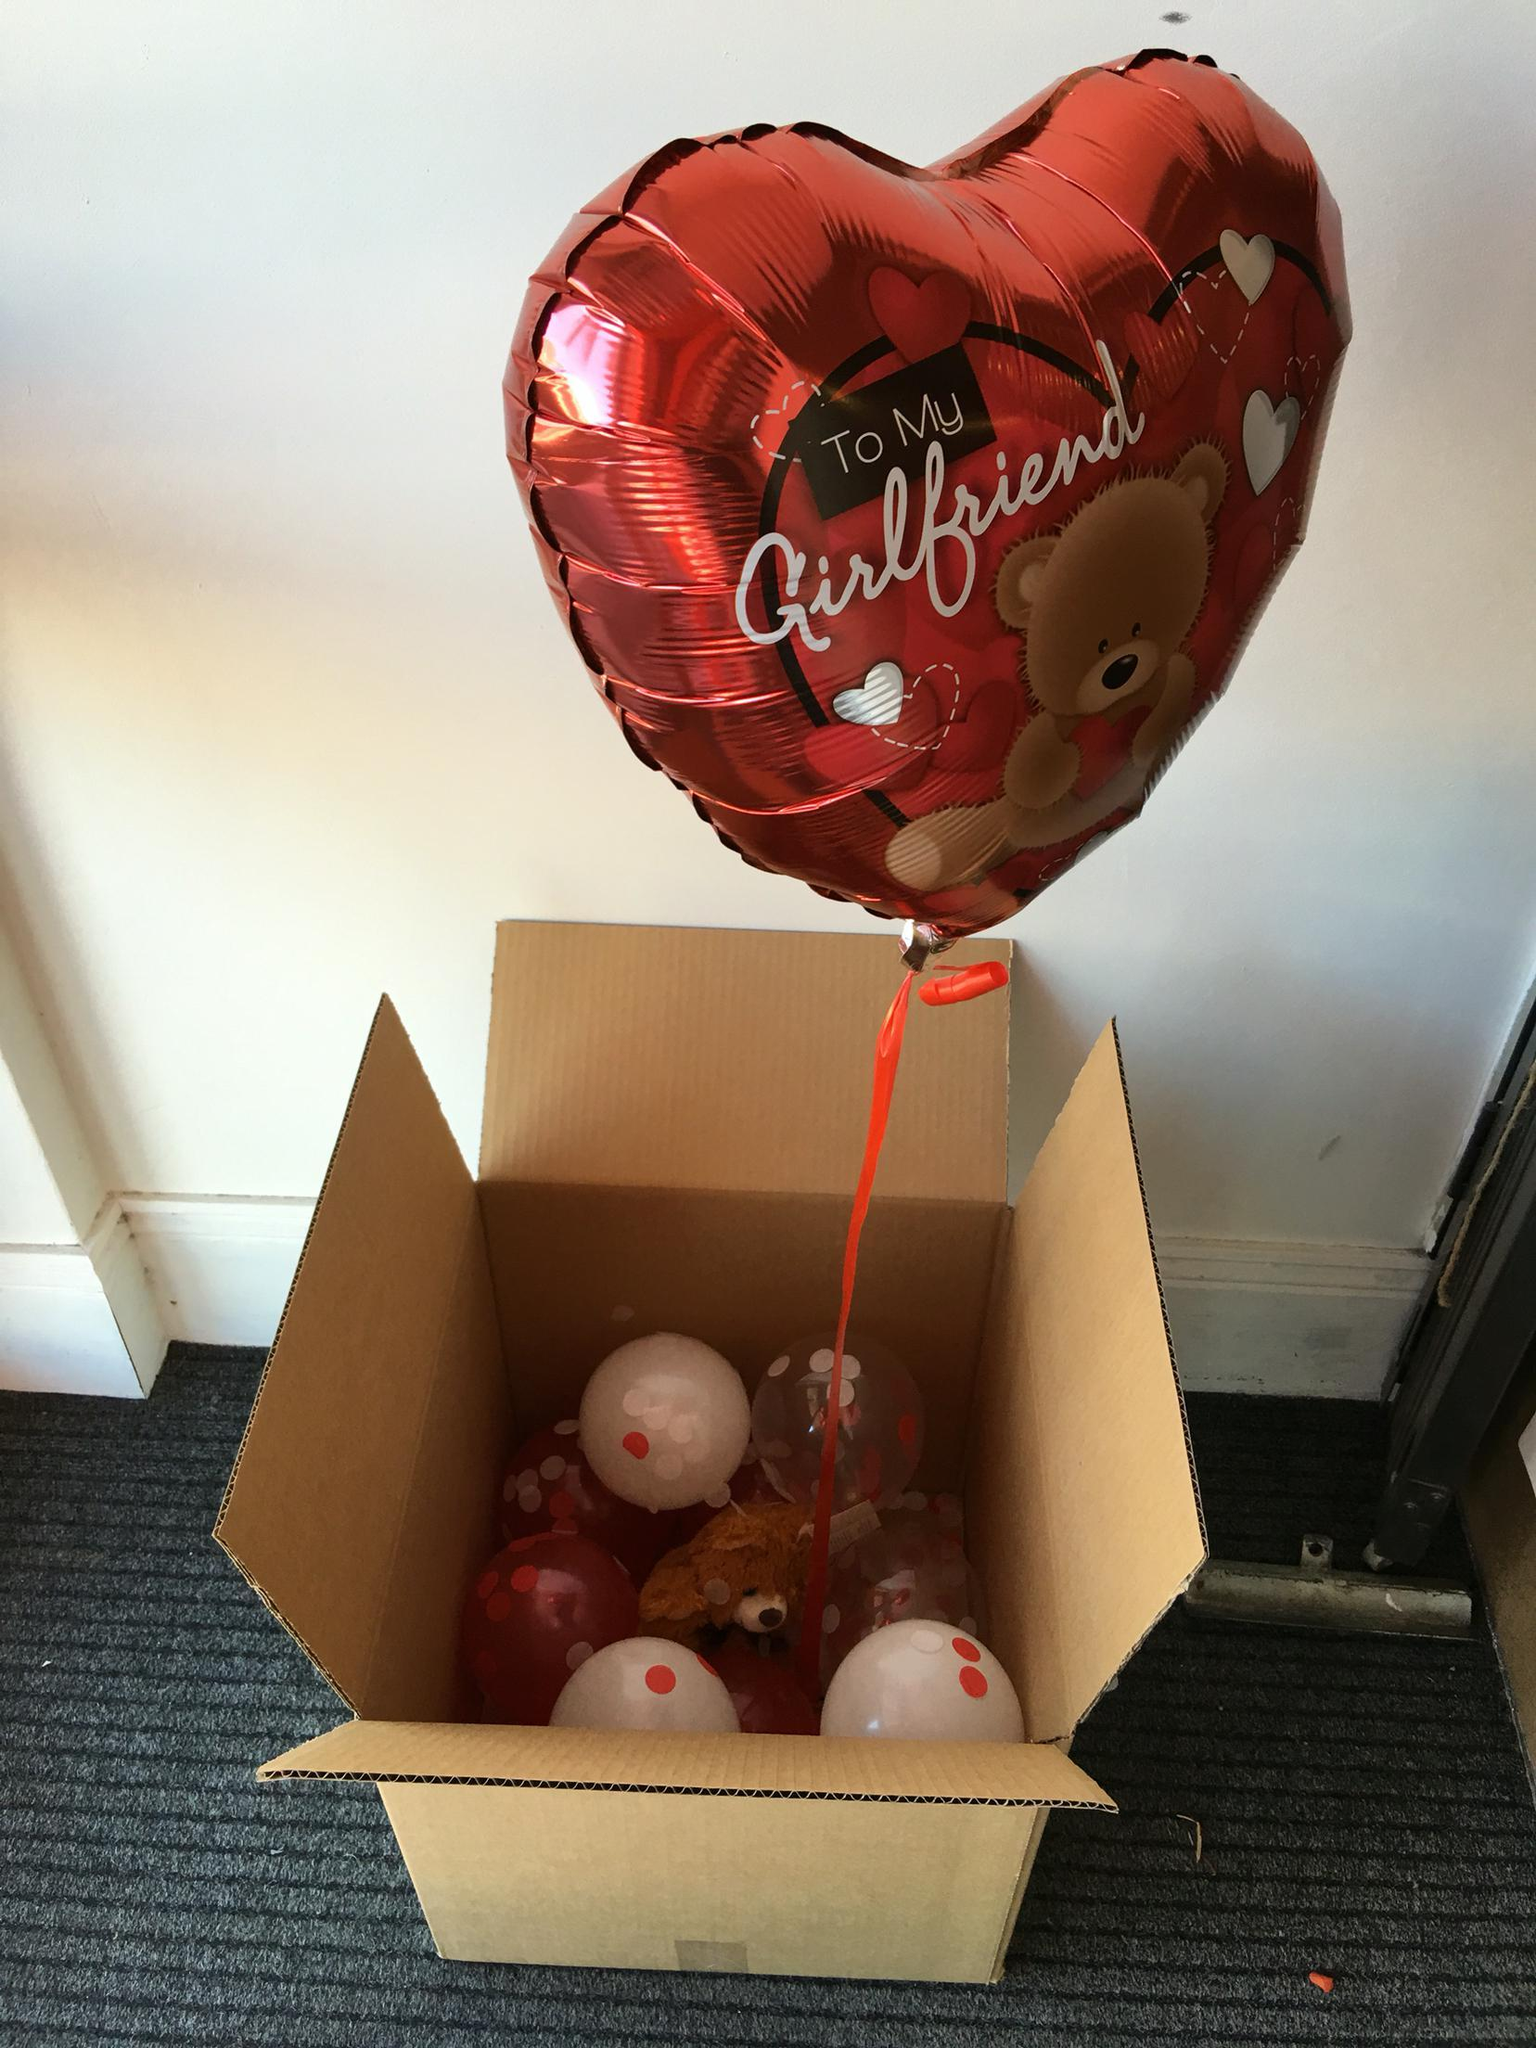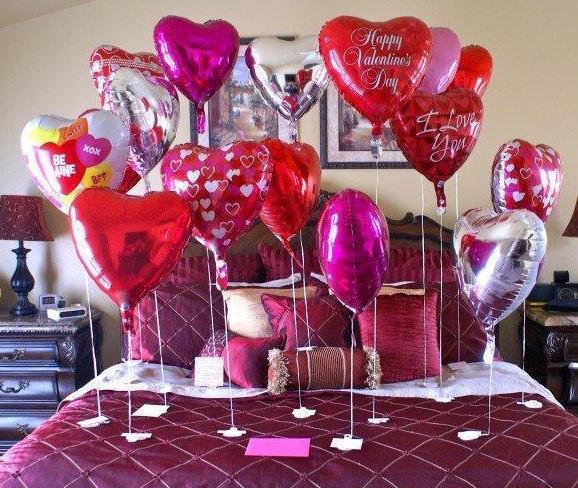The first image is the image on the left, the second image is the image on the right. Assess this claim about the two images: "There is a man outside walking with at least ten red balloons.". Correct or not? Answer yes or no. No. The first image is the image on the left, the second image is the image on the right. Given the left and right images, does the statement "There is a heart shaped balloon in both images." hold true? Answer yes or no. Yes. 